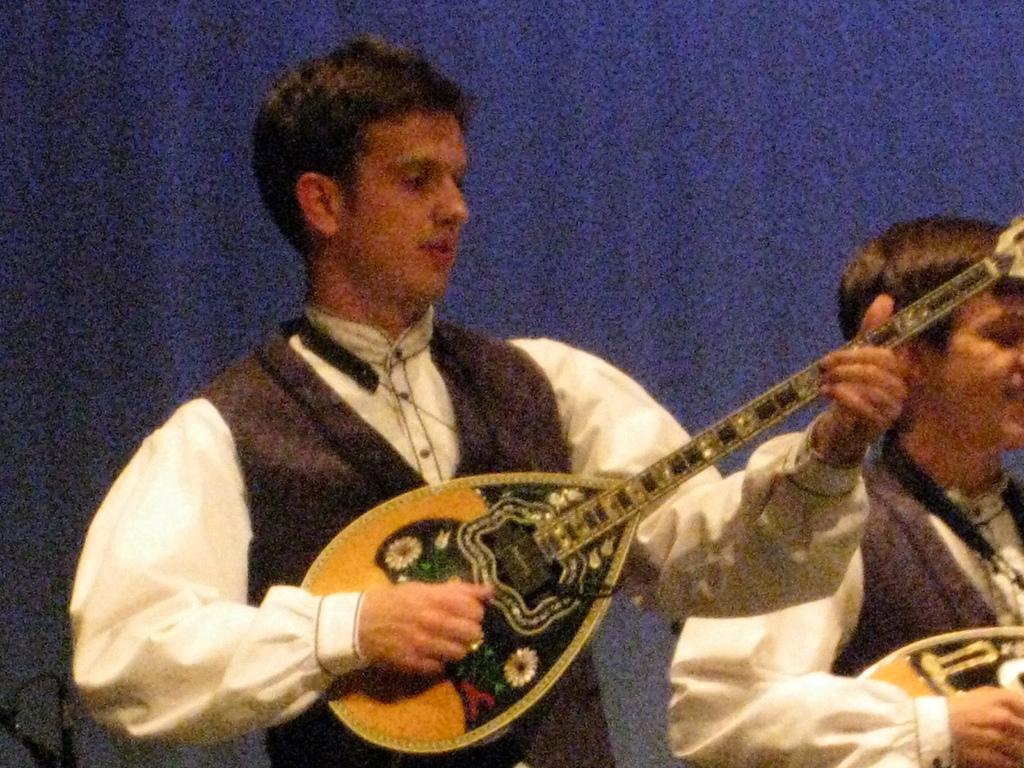What is the man in the image doing with his hands? The man is playing a musical instrument with his hands. Can you describe the other person in the image? There is another man beside him. What can be seen behind the two men? There is a blue screen behind them. What type of nerve can be seen in the image? There is no nerve visible in the image. Can you tell me how many cups are on the table in the image? There is no table or cups present in the image. 